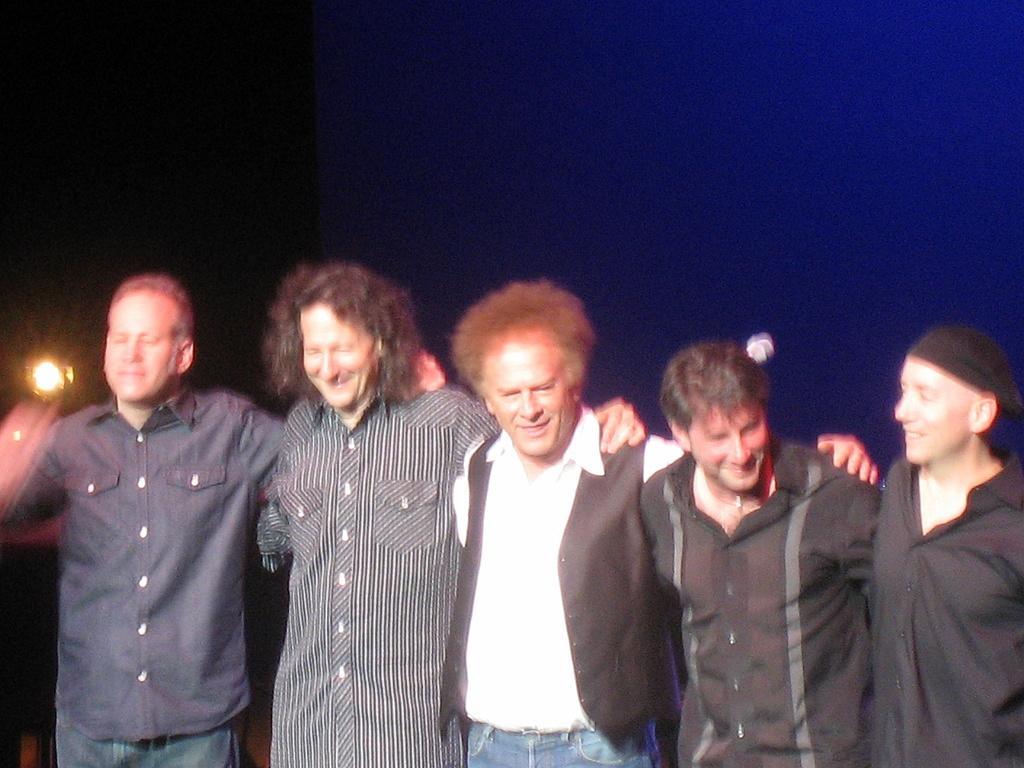Please provide a concise description of this image. In this image we can see few persons. In the background there is a light and the image is not clear to describe. 